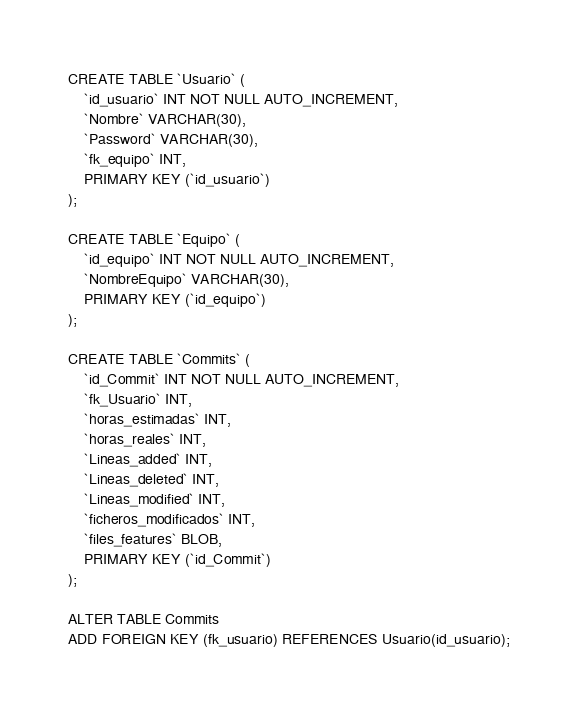Convert code to text. <code><loc_0><loc_0><loc_500><loc_500><_SQL_>CREATE TABLE `Usuario` (
	`id_usuario` INT NOT NULL AUTO_INCREMENT,
	`Nombre` VARCHAR(30),
	`Password` VARCHAR(30),
	`fk_equipo` INT,
	PRIMARY KEY (`id_usuario`)
);

CREATE TABLE `Equipo` (
	`id_equipo` INT NOT NULL AUTO_INCREMENT,
	`NombreEquipo` VARCHAR(30),
	PRIMARY KEY (`id_equipo`)
);

CREATE TABLE `Commits` (
	`id_Commit` INT NOT NULL AUTO_INCREMENT,
	`fk_Usuario` INT,
	`horas_estimadas` INT,
	`horas_reales` INT,
	`Lineas_added` INT,
	`Lineas_deleted` INT,
	`Lineas_modified` INT,
	`ficheros_modificados` INT,
	`files_features` BLOB,
	PRIMARY KEY (`id_Commit`)
);

ALTER TABLE Commits
ADD FOREIGN KEY (fk_usuario) REFERENCES Usuario(id_usuario);
</code> 